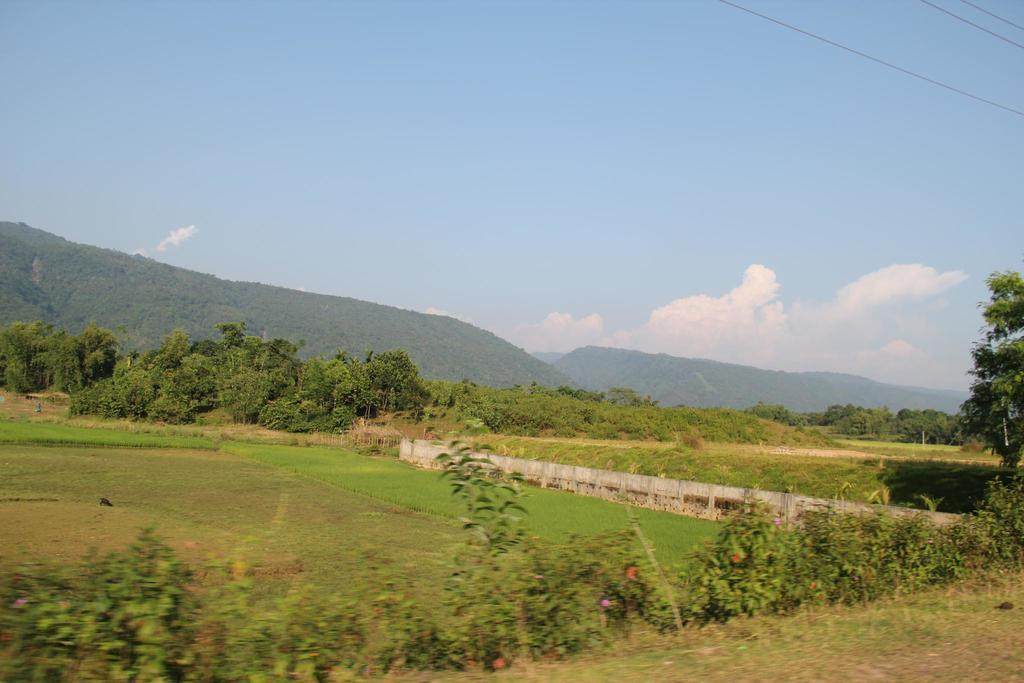What type of ground covering is visible in the image? The ground in the image is covered with grass. What other natural elements can be seen in the image? There are plants and many trees in the image. What is the primary man-made feature in the image? There is a road in the middle of the image. What type of wall can be seen in the image? There is no wall present in the image; it features grass-covered ground, plants, trees, and a road. What scientific theory is being demonstrated in the image? There is no scientific theory being demonstrated in the image; it is a simple scene of natural and man-made elements. 